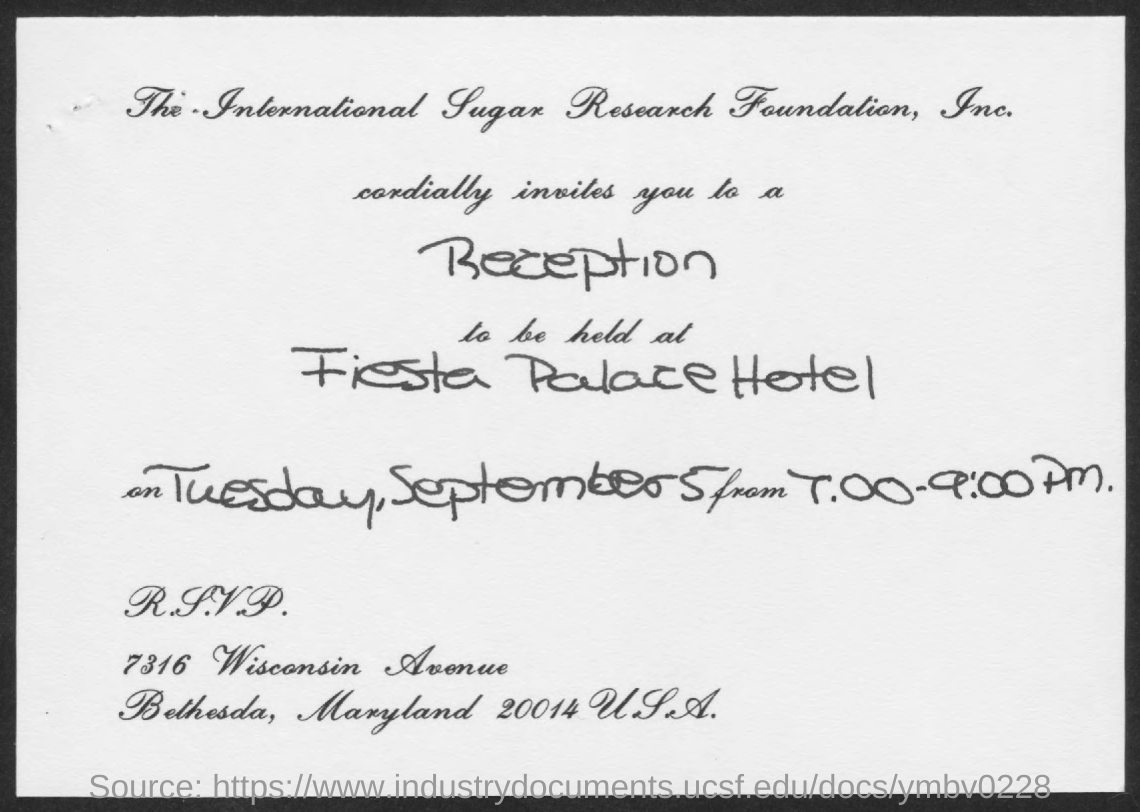Specify some key components in this picture. The document specifies that the date is Tuesday, September 5. The reception for the event will be held at the Fiesta Palace Hotel. 